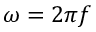<formula> <loc_0><loc_0><loc_500><loc_500>\omega = 2 { \pi } f</formula> 